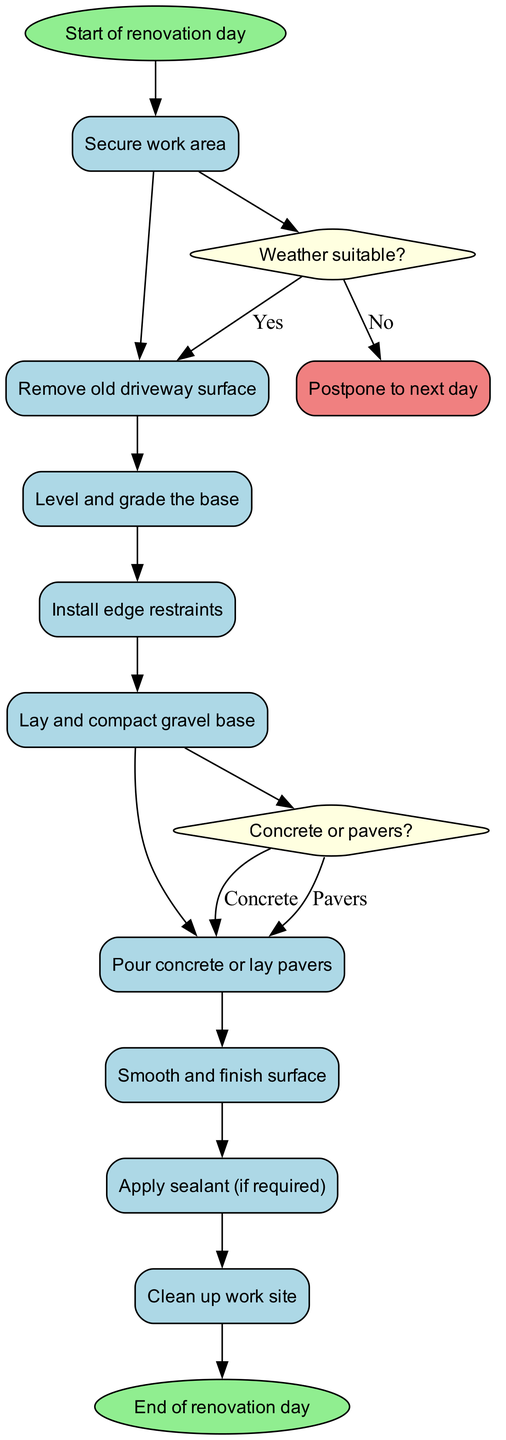What is the first activity in the diagram? The diagram starts with the node labeled "Start of renovation day," which leads to the first activity. The first activity (after the start node) is "Secure work area."
Answer: Secure work area How many activities are listed in the diagram? Counting the activities shown in the diagram, there are a total of nine distinct activities from "Secure work area" to "Clean up work site."
Answer: Nine What happens if the weather is not suitable? According to the decision point labeled "Weather suitable?", if the answer is 'No', the next action taken is "Postpone to next day," which specifies that work will not continue as planned.
Answer: Postpone to next day What activity follows the decision point about weather suitability when the answer is 'Yes'? When the weather is deemed suitable (answer 'Yes'), the workflow continues directly to the next activity, which is "Remove old driveway surface."
Answer: Remove old driveway surface What are the two options after leveling the base? After leveling and grading the base, the diagram has a decision point labeled "Concrete or pavers?" At this decision point, the two options are to either "Pour concrete" or "Lay pavers."
Answer: Pour concrete or lay pavers How many decision points are there in the diagram? There are two decision points within the activity diagram: one concerning the weather and one concerning the choice between concrete and pavers.
Answer: Two What is the final activity before the end of the renovation day? Before reaching the end of the renovation day, the last activity performed is "Apply sealant (if required)." This is the step that comes just before concluding the process.
Answer: Apply sealant (if required) 